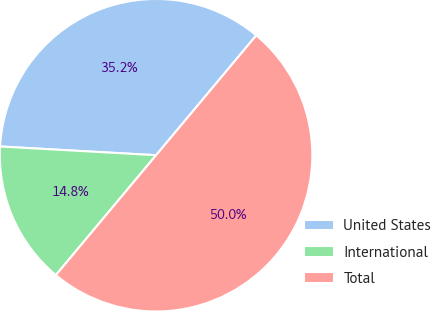<chart> <loc_0><loc_0><loc_500><loc_500><pie_chart><fcel>United States<fcel>International<fcel>Total<nl><fcel>35.19%<fcel>14.81%<fcel>50.0%<nl></chart> 